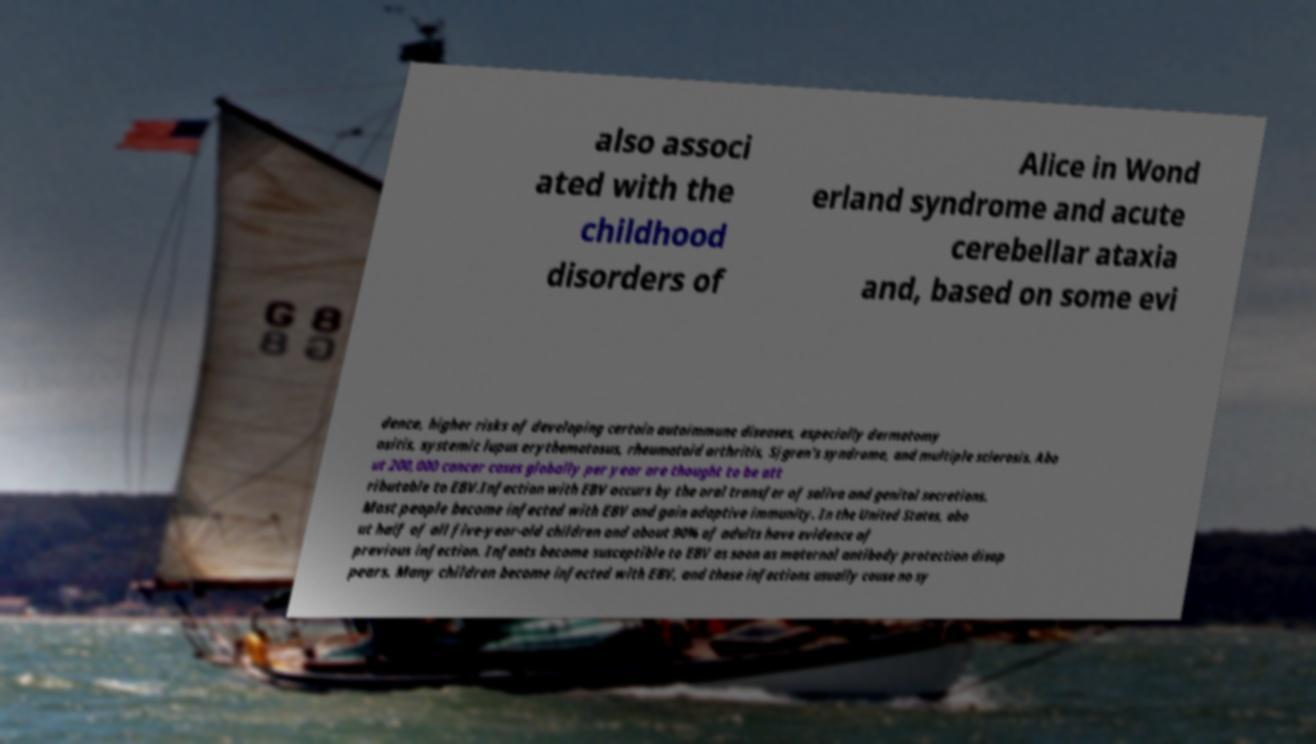There's text embedded in this image that I need extracted. Can you transcribe it verbatim? also associ ated with the childhood disorders of Alice in Wond erland syndrome and acute cerebellar ataxia and, based on some evi dence, higher risks of developing certain autoimmune diseases, especially dermatomy ositis, systemic lupus erythematosus, rheumatoid arthritis, Sjgren's syndrome, and multiple sclerosis. Abo ut 200,000 cancer cases globally per year are thought to be att ributable to EBV.Infection with EBV occurs by the oral transfer of saliva and genital secretions. Most people become infected with EBV and gain adaptive immunity. In the United States, abo ut half of all five-year-old children and about 90% of adults have evidence of previous infection. Infants become susceptible to EBV as soon as maternal antibody protection disap pears. Many children become infected with EBV, and these infections usually cause no sy 